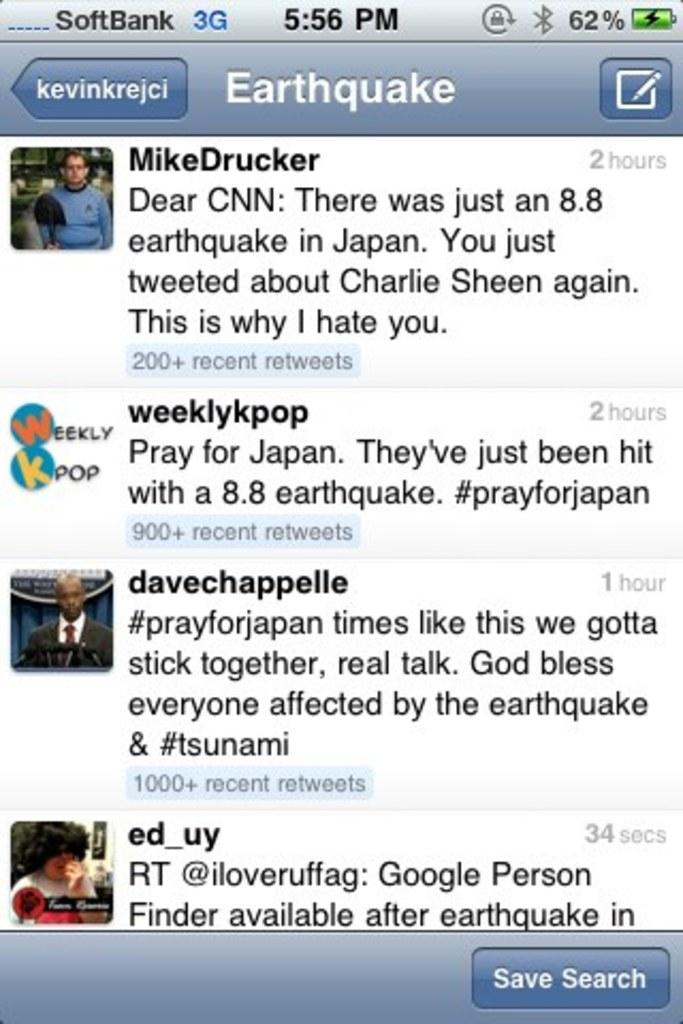What is displayed on the screen in the image? There are images of persons on the screen. What else can be seen on the screen besides the images of persons? There is something written on the screen and there are icons on the screen. What type of bucket is used to collect quartz in the image? There is no bucket or quartz present in the image. What type of education is being taught on the screen in the image? The image does not depict any educational content; it only shows images of persons, written text, and icons on the screen. 